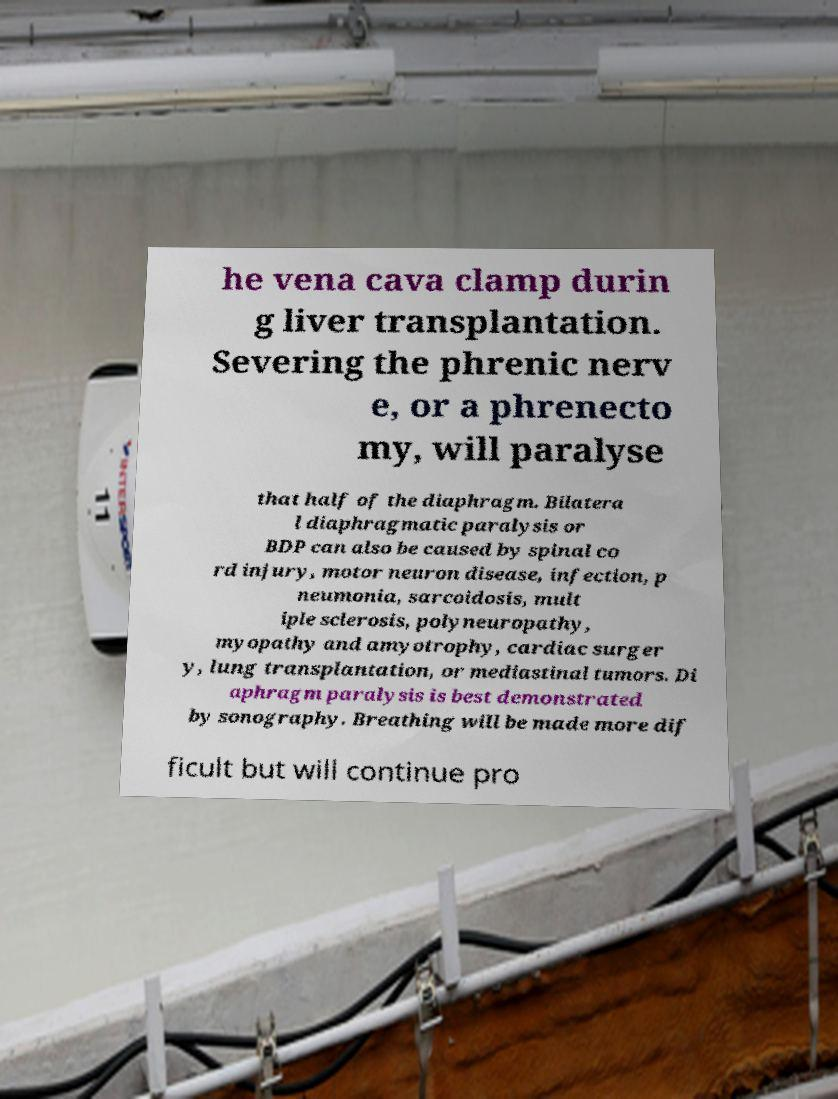I need the written content from this picture converted into text. Can you do that? he vena cava clamp durin g liver transplantation. Severing the phrenic nerv e, or a phrenecto my, will paralyse that half of the diaphragm. Bilatera l diaphragmatic paralysis or BDP can also be caused by spinal co rd injury, motor neuron disease, infection, p neumonia, sarcoidosis, mult iple sclerosis, polyneuropathy, myopathy and amyotrophy, cardiac surger y, lung transplantation, or mediastinal tumors. Di aphragm paralysis is best demonstrated by sonography. Breathing will be made more dif ficult but will continue pro 